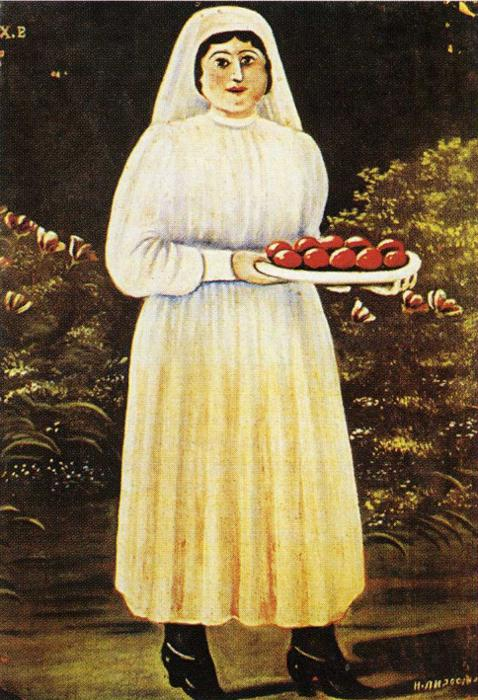Can you tell more about the symbolism of the apples in this painting? Certainly! In many cultures, apples are regarded as symbols of knowledge, immortality, temptation, and harvest. In this artwork, their vibrant red color and the bountiful amount embodies the themes of abundance and fertility. The artist uses these apples not only as a central visual focus but also to evoke a sense of prosperous and fruitful times. What does the color contrast in the painting tell us? The stark contrast between the bright white and red colors against the dark background is quite striking. This could be interpreted as a representation of life and vitality standing out amidst the darker, more challenging aspects of existence. The light attire of the woman and the vivid apples suggest themes of purity, hope, and renewal, which vividly come through despite the somber tones surrounding them. 